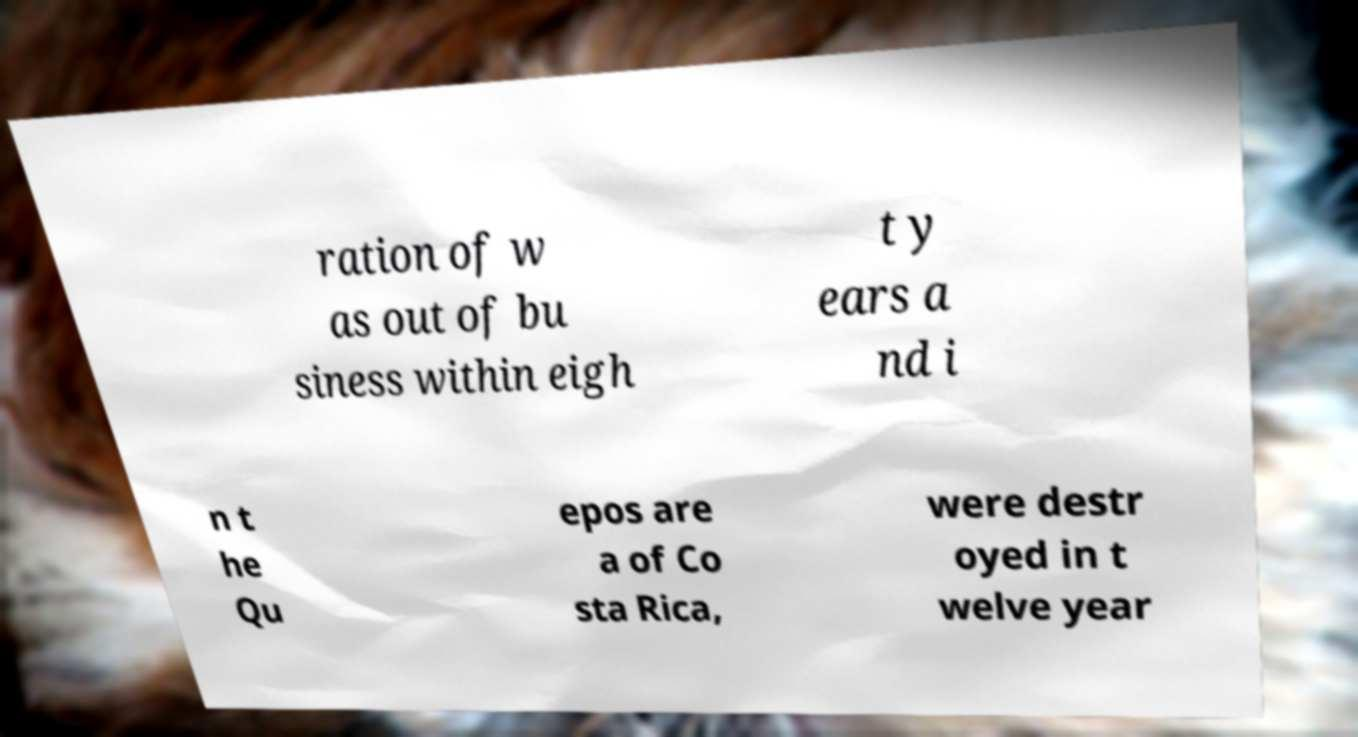Can you accurately transcribe the text from the provided image for me? ration of w as out of bu siness within eigh t y ears a nd i n t he Qu epos are a of Co sta Rica, were destr oyed in t welve year 